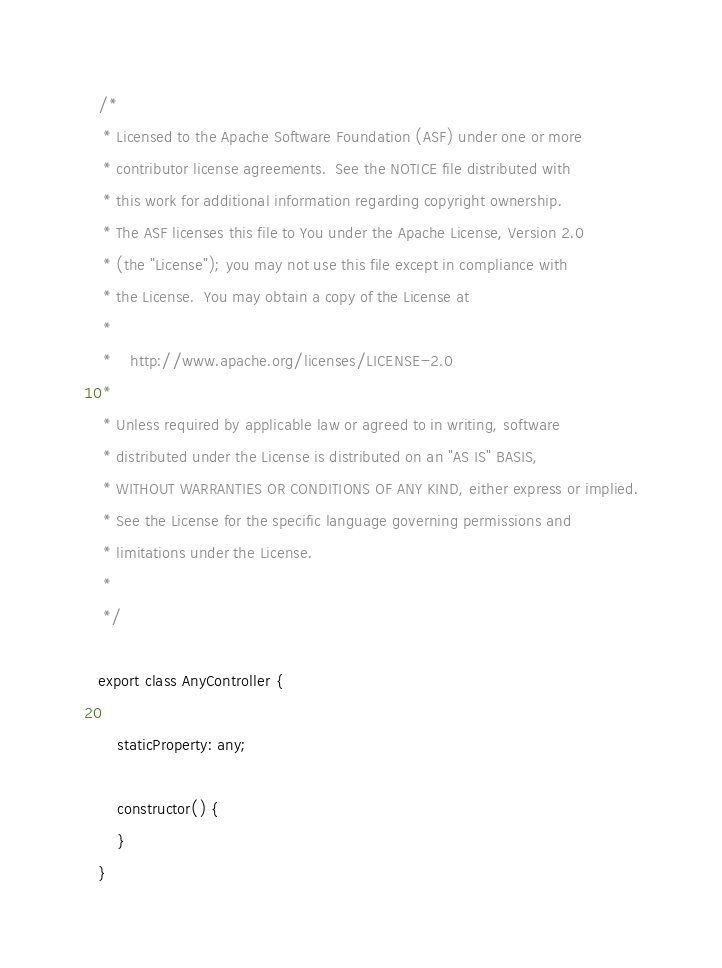<code> <loc_0><loc_0><loc_500><loc_500><_TypeScript_>/*
 * Licensed to the Apache Software Foundation (ASF) under one or more
 * contributor license agreements.  See the NOTICE file distributed with
 * this work for additional information regarding copyright ownership.
 * The ASF licenses this file to You under the Apache License, Version 2.0
 * (the "License"); you may not use this file except in compliance with
 * the License.  You may obtain a copy of the License at
 *
 *    http://www.apache.org/licenses/LICENSE-2.0
 *
 * Unless required by applicable law or agreed to in writing, software
 * distributed under the License is distributed on an "AS IS" BASIS,
 * WITHOUT WARRANTIES OR CONDITIONS OF ANY KIND, either express or implied.
 * See the License for the specific language governing permissions and
 * limitations under the License.
 *
 */

export class AnyController {

    staticProperty: any;

    constructor() {
    }
}</code> 